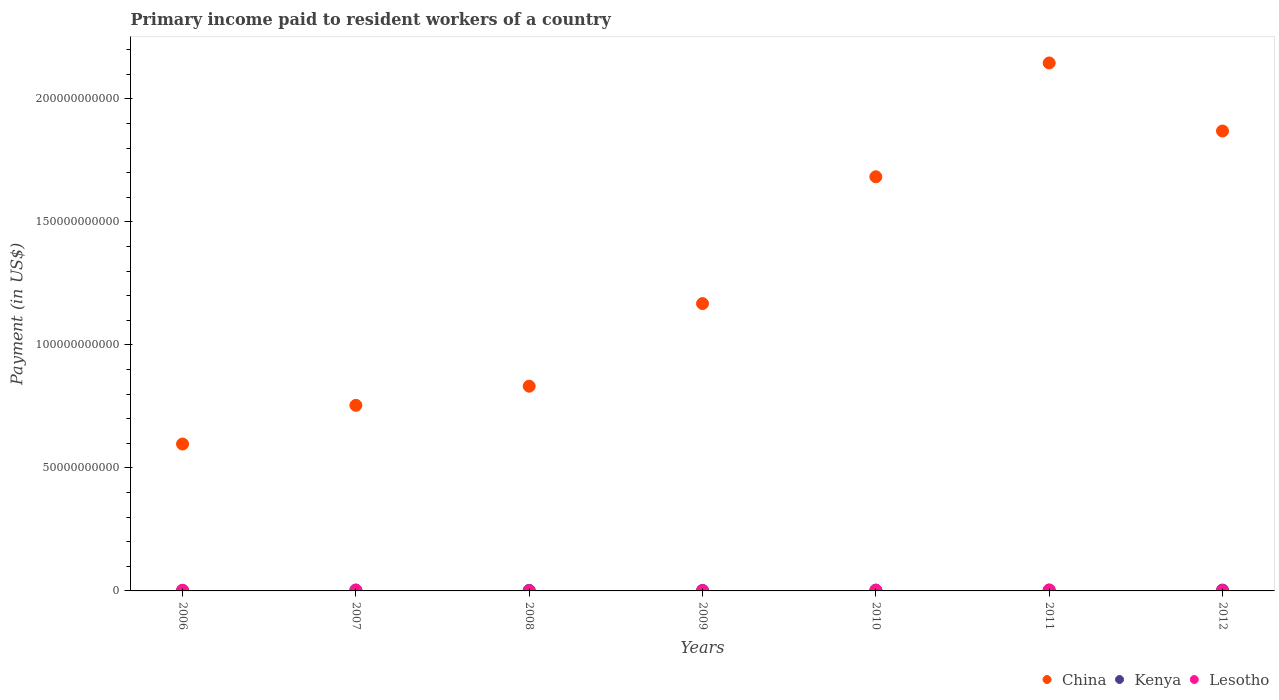Is the number of dotlines equal to the number of legend labels?
Provide a short and direct response. Yes. What is the amount paid to workers in Kenya in 2006?
Your response must be concise. 1.70e+08. Across all years, what is the maximum amount paid to workers in Kenya?
Provide a short and direct response. 3.50e+08. Across all years, what is the minimum amount paid to workers in Kenya?
Offer a terse response. 1.70e+08. In which year was the amount paid to workers in Lesotho maximum?
Your response must be concise. 2011. What is the total amount paid to workers in Lesotho in the graph?
Make the answer very short. 1.71e+09. What is the difference between the amount paid to workers in China in 2009 and that in 2010?
Provide a short and direct response. -5.15e+1. What is the difference between the amount paid to workers in Lesotho in 2008 and the amount paid to workers in Kenya in 2012?
Your answer should be very brief. -2.51e+08. What is the average amount paid to workers in Lesotho per year?
Your answer should be very brief. 2.44e+08. In the year 2008, what is the difference between the amount paid to workers in Lesotho and amount paid to workers in Kenya?
Ensure brevity in your answer.  -1.22e+08. What is the ratio of the amount paid to workers in China in 2007 to that in 2009?
Your answer should be compact. 0.65. Is the difference between the amount paid to workers in Lesotho in 2009 and 2011 greater than the difference between the amount paid to workers in Kenya in 2009 and 2011?
Your response must be concise. No. What is the difference between the highest and the second highest amount paid to workers in Lesotho?
Your answer should be very brief. 2.51e+07. What is the difference between the highest and the lowest amount paid to workers in Kenya?
Ensure brevity in your answer.  1.81e+08. Is the amount paid to workers in China strictly less than the amount paid to workers in Kenya over the years?
Provide a short and direct response. No. How many dotlines are there?
Ensure brevity in your answer.  3. How many years are there in the graph?
Provide a short and direct response. 7. Does the graph contain any zero values?
Provide a short and direct response. No. Does the graph contain grids?
Your answer should be compact. No. Where does the legend appear in the graph?
Provide a short and direct response. Bottom right. How are the legend labels stacked?
Offer a terse response. Horizontal. What is the title of the graph?
Give a very brief answer. Primary income paid to resident workers of a country. Does "Marshall Islands" appear as one of the legend labels in the graph?
Offer a very short reply. No. What is the label or title of the Y-axis?
Your response must be concise. Payment (in US$). What is the Payment (in US$) of China in 2006?
Offer a very short reply. 5.97e+1. What is the Payment (in US$) in Kenya in 2006?
Your response must be concise. 1.70e+08. What is the Payment (in US$) of Lesotho in 2006?
Your response must be concise. 2.65e+08. What is the Payment (in US$) in China in 2007?
Your answer should be compact. 7.54e+1. What is the Payment (in US$) in Kenya in 2007?
Keep it short and to the point. 3.05e+08. What is the Payment (in US$) in Lesotho in 2007?
Provide a succinct answer. 3.70e+08. What is the Payment (in US$) in China in 2008?
Provide a short and direct response. 8.32e+1. What is the Payment (in US$) of Kenya in 2008?
Offer a very short reply. 2.21e+08. What is the Payment (in US$) in Lesotho in 2008?
Your answer should be very brief. 9.93e+07. What is the Payment (in US$) in China in 2009?
Provide a succinct answer. 1.17e+11. What is the Payment (in US$) in Kenya in 2009?
Keep it short and to the point. 2.12e+08. What is the Payment (in US$) of Lesotho in 2009?
Offer a very short reply. 1.25e+08. What is the Payment (in US$) of China in 2010?
Provide a short and direct response. 1.68e+11. What is the Payment (in US$) of Kenya in 2010?
Make the answer very short. 2.92e+08. What is the Payment (in US$) in Lesotho in 2010?
Give a very brief answer. 3.25e+08. What is the Payment (in US$) in China in 2011?
Keep it short and to the point. 2.15e+11. What is the Payment (in US$) in Kenya in 2011?
Your answer should be very brief. 2.83e+08. What is the Payment (in US$) in Lesotho in 2011?
Give a very brief answer. 3.95e+08. What is the Payment (in US$) of China in 2012?
Provide a succinct answer. 1.87e+11. What is the Payment (in US$) of Kenya in 2012?
Keep it short and to the point. 3.50e+08. What is the Payment (in US$) of Lesotho in 2012?
Your answer should be compact. 1.28e+08. Across all years, what is the maximum Payment (in US$) in China?
Provide a succinct answer. 2.15e+11. Across all years, what is the maximum Payment (in US$) in Kenya?
Your answer should be compact. 3.50e+08. Across all years, what is the maximum Payment (in US$) in Lesotho?
Your answer should be very brief. 3.95e+08. Across all years, what is the minimum Payment (in US$) of China?
Ensure brevity in your answer.  5.97e+1. Across all years, what is the minimum Payment (in US$) in Kenya?
Your response must be concise. 1.70e+08. Across all years, what is the minimum Payment (in US$) in Lesotho?
Offer a very short reply. 9.93e+07. What is the total Payment (in US$) of China in the graph?
Offer a very short reply. 9.05e+11. What is the total Payment (in US$) of Kenya in the graph?
Make the answer very short. 1.83e+09. What is the total Payment (in US$) in Lesotho in the graph?
Give a very brief answer. 1.71e+09. What is the difference between the Payment (in US$) of China in 2006 and that in 2007?
Offer a very short reply. -1.57e+1. What is the difference between the Payment (in US$) of Kenya in 2006 and that in 2007?
Offer a very short reply. -1.35e+08. What is the difference between the Payment (in US$) in Lesotho in 2006 and that in 2007?
Your answer should be very brief. -1.05e+08. What is the difference between the Payment (in US$) of China in 2006 and that in 2008?
Make the answer very short. -2.35e+1. What is the difference between the Payment (in US$) in Kenya in 2006 and that in 2008?
Keep it short and to the point. -5.19e+07. What is the difference between the Payment (in US$) of Lesotho in 2006 and that in 2008?
Ensure brevity in your answer.  1.66e+08. What is the difference between the Payment (in US$) of China in 2006 and that in 2009?
Offer a terse response. -5.71e+1. What is the difference between the Payment (in US$) in Kenya in 2006 and that in 2009?
Your answer should be compact. -4.28e+07. What is the difference between the Payment (in US$) of Lesotho in 2006 and that in 2009?
Provide a succinct answer. 1.40e+08. What is the difference between the Payment (in US$) in China in 2006 and that in 2010?
Offer a very short reply. -1.09e+11. What is the difference between the Payment (in US$) of Kenya in 2006 and that in 2010?
Give a very brief answer. -1.22e+08. What is the difference between the Payment (in US$) in Lesotho in 2006 and that in 2010?
Your response must be concise. -5.99e+07. What is the difference between the Payment (in US$) in China in 2006 and that in 2011?
Keep it short and to the point. -1.55e+11. What is the difference between the Payment (in US$) in Kenya in 2006 and that in 2011?
Ensure brevity in your answer.  -1.13e+08. What is the difference between the Payment (in US$) of Lesotho in 2006 and that in 2011?
Offer a very short reply. -1.30e+08. What is the difference between the Payment (in US$) of China in 2006 and that in 2012?
Offer a terse response. -1.27e+11. What is the difference between the Payment (in US$) in Kenya in 2006 and that in 2012?
Offer a terse response. -1.81e+08. What is the difference between the Payment (in US$) in Lesotho in 2006 and that in 2012?
Ensure brevity in your answer.  1.37e+08. What is the difference between the Payment (in US$) of China in 2007 and that in 2008?
Your answer should be very brief. -7.78e+09. What is the difference between the Payment (in US$) of Kenya in 2007 and that in 2008?
Provide a short and direct response. 8.34e+07. What is the difference between the Payment (in US$) in Lesotho in 2007 and that in 2008?
Give a very brief answer. 2.70e+08. What is the difference between the Payment (in US$) in China in 2007 and that in 2009?
Offer a terse response. -4.14e+1. What is the difference between the Payment (in US$) in Kenya in 2007 and that in 2009?
Ensure brevity in your answer.  9.24e+07. What is the difference between the Payment (in US$) in Lesotho in 2007 and that in 2009?
Your answer should be compact. 2.45e+08. What is the difference between the Payment (in US$) in China in 2007 and that in 2010?
Your response must be concise. -9.29e+1. What is the difference between the Payment (in US$) in Kenya in 2007 and that in 2010?
Provide a succinct answer. 1.29e+07. What is the difference between the Payment (in US$) in Lesotho in 2007 and that in 2010?
Your response must be concise. 4.47e+07. What is the difference between the Payment (in US$) of China in 2007 and that in 2011?
Offer a terse response. -1.39e+11. What is the difference between the Payment (in US$) of Kenya in 2007 and that in 2011?
Keep it short and to the point. 2.23e+07. What is the difference between the Payment (in US$) of Lesotho in 2007 and that in 2011?
Keep it short and to the point. -2.51e+07. What is the difference between the Payment (in US$) of China in 2007 and that in 2012?
Give a very brief answer. -1.11e+11. What is the difference between the Payment (in US$) of Kenya in 2007 and that in 2012?
Make the answer very short. -4.56e+07. What is the difference between the Payment (in US$) in Lesotho in 2007 and that in 2012?
Your answer should be very brief. 2.42e+08. What is the difference between the Payment (in US$) of China in 2008 and that in 2009?
Your answer should be compact. -3.36e+1. What is the difference between the Payment (in US$) of Kenya in 2008 and that in 2009?
Your answer should be very brief. 9.07e+06. What is the difference between the Payment (in US$) in Lesotho in 2008 and that in 2009?
Provide a short and direct response. -2.55e+07. What is the difference between the Payment (in US$) of China in 2008 and that in 2010?
Keep it short and to the point. -8.51e+1. What is the difference between the Payment (in US$) in Kenya in 2008 and that in 2010?
Keep it short and to the point. -7.04e+07. What is the difference between the Payment (in US$) in Lesotho in 2008 and that in 2010?
Your answer should be very brief. -2.26e+08. What is the difference between the Payment (in US$) in China in 2008 and that in 2011?
Provide a short and direct response. -1.31e+11. What is the difference between the Payment (in US$) of Kenya in 2008 and that in 2011?
Give a very brief answer. -6.11e+07. What is the difference between the Payment (in US$) of Lesotho in 2008 and that in 2011?
Give a very brief answer. -2.96e+08. What is the difference between the Payment (in US$) of China in 2008 and that in 2012?
Your answer should be very brief. -1.04e+11. What is the difference between the Payment (in US$) in Kenya in 2008 and that in 2012?
Your answer should be very brief. -1.29e+08. What is the difference between the Payment (in US$) in Lesotho in 2008 and that in 2012?
Offer a terse response. -2.85e+07. What is the difference between the Payment (in US$) of China in 2009 and that in 2010?
Your response must be concise. -5.15e+1. What is the difference between the Payment (in US$) of Kenya in 2009 and that in 2010?
Offer a very short reply. -7.95e+07. What is the difference between the Payment (in US$) of Lesotho in 2009 and that in 2010?
Ensure brevity in your answer.  -2.00e+08. What is the difference between the Payment (in US$) of China in 2009 and that in 2011?
Keep it short and to the point. -9.78e+1. What is the difference between the Payment (in US$) of Kenya in 2009 and that in 2011?
Provide a short and direct response. -7.02e+07. What is the difference between the Payment (in US$) of Lesotho in 2009 and that in 2011?
Give a very brief answer. -2.70e+08. What is the difference between the Payment (in US$) in China in 2009 and that in 2012?
Provide a short and direct response. -7.01e+1. What is the difference between the Payment (in US$) of Kenya in 2009 and that in 2012?
Offer a terse response. -1.38e+08. What is the difference between the Payment (in US$) of Lesotho in 2009 and that in 2012?
Offer a very short reply. -3.08e+06. What is the difference between the Payment (in US$) of China in 2010 and that in 2011?
Ensure brevity in your answer.  -4.63e+1. What is the difference between the Payment (in US$) of Kenya in 2010 and that in 2011?
Make the answer very short. 9.34e+06. What is the difference between the Payment (in US$) in Lesotho in 2010 and that in 2011?
Provide a short and direct response. -6.97e+07. What is the difference between the Payment (in US$) of China in 2010 and that in 2012?
Provide a succinct answer. -1.86e+1. What is the difference between the Payment (in US$) of Kenya in 2010 and that in 2012?
Provide a short and direct response. -5.85e+07. What is the difference between the Payment (in US$) of Lesotho in 2010 and that in 2012?
Ensure brevity in your answer.  1.97e+08. What is the difference between the Payment (in US$) of China in 2011 and that in 2012?
Your answer should be very brief. 2.77e+1. What is the difference between the Payment (in US$) of Kenya in 2011 and that in 2012?
Provide a short and direct response. -6.79e+07. What is the difference between the Payment (in US$) of Lesotho in 2011 and that in 2012?
Your answer should be very brief. 2.67e+08. What is the difference between the Payment (in US$) of China in 2006 and the Payment (in US$) of Kenya in 2007?
Offer a very short reply. 5.94e+1. What is the difference between the Payment (in US$) of China in 2006 and the Payment (in US$) of Lesotho in 2007?
Give a very brief answer. 5.93e+1. What is the difference between the Payment (in US$) in Kenya in 2006 and the Payment (in US$) in Lesotho in 2007?
Keep it short and to the point. -2.00e+08. What is the difference between the Payment (in US$) of China in 2006 and the Payment (in US$) of Kenya in 2008?
Your answer should be compact. 5.95e+1. What is the difference between the Payment (in US$) in China in 2006 and the Payment (in US$) in Lesotho in 2008?
Make the answer very short. 5.96e+1. What is the difference between the Payment (in US$) in Kenya in 2006 and the Payment (in US$) in Lesotho in 2008?
Make the answer very short. 7.02e+07. What is the difference between the Payment (in US$) of China in 2006 and the Payment (in US$) of Kenya in 2009?
Offer a very short reply. 5.95e+1. What is the difference between the Payment (in US$) of China in 2006 and the Payment (in US$) of Lesotho in 2009?
Your response must be concise. 5.96e+1. What is the difference between the Payment (in US$) in Kenya in 2006 and the Payment (in US$) in Lesotho in 2009?
Give a very brief answer. 4.47e+07. What is the difference between the Payment (in US$) of China in 2006 and the Payment (in US$) of Kenya in 2010?
Offer a very short reply. 5.94e+1. What is the difference between the Payment (in US$) of China in 2006 and the Payment (in US$) of Lesotho in 2010?
Give a very brief answer. 5.94e+1. What is the difference between the Payment (in US$) of Kenya in 2006 and the Payment (in US$) of Lesotho in 2010?
Offer a terse response. -1.56e+08. What is the difference between the Payment (in US$) of China in 2006 and the Payment (in US$) of Kenya in 2011?
Keep it short and to the point. 5.94e+1. What is the difference between the Payment (in US$) of China in 2006 and the Payment (in US$) of Lesotho in 2011?
Give a very brief answer. 5.93e+1. What is the difference between the Payment (in US$) in Kenya in 2006 and the Payment (in US$) in Lesotho in 2011?
Offer a very short reply. -2.25e+08. What is the difference between the Payment (in US$) of China in 2006 and the Payment (in US$) of Kenya in 2012?
Make the answer very short. 5.94e+1. What is the difference between the Payment (in US$) of China in 2006 and the Payment (in US$) of Lesotho in 2012?
Your response must be concise. 5.96e+1. What is the difference between the Payment (in US$) of Kenya in 2006 and the Payment (in US$) of Lesotho in 2012?
Ensure brevity in your answer.  4.16e+07. What is the difference between the Payment (in US$) of China in 2007 and the Payment (in US$) of Kenya in 2008?
Ensure brevity in your answer.  7.52e+1. What is the difference between the Payment (in US$) of China in 2007 and the Payment (in US$) of Lesotho in 2008?
Make the answer very short. 7.53e+1. What is the difference between the Payment (in US$) in Kenya in 2007 and the Payment (in US$) in Lesotho in 2008?
Give a very brief answer. 2.05e+08. What is the difference between the Payment (in US$) in China in 2007 and the Payment (in US$) in Kenya in 2009?
Ensure brevity in your answer.  7.52e+1. What is the difference between the Payment (in US$) of China in 2007 and the Payment (in US$) of Lesotho in 2009?
Offer a very short reply. 7.53e+1. What is the difference between the Payment (in US$) of Kenya in 2007 and the Payment (in US$) of Lesotho in 2009?
Offer a terse response. 1.80e+08. What is the difference between the Payment (in US$) of China in 2007 and the Payment (in US$) of Kenya in 2010?
Your answer should be very brief. 7.51e+1. What is the difference between the Payment (in US$) in China in 2007 and the Payment (in US$) in Lesotho in 2010?
Provide a succinct answer. 7.51e+1. What is the difference between the Payment (in US$) in Kenya in 2007 and the Payment (in US$) in Lesotho in 2010?
Ensure brevity in your answer.  -2.04e+07. What is the difference between the Payment (in US$) in China in 2007 and the Payment (in US$) in Kenya in 2011?
Give a very brief answer. 7.51e+1. What is the difference between the Payment (in US$) of China in 2007 and the Payment (in US$) of Lesotho in 2011?
Make the answer very short. 7.50e+1. What is the difference between the Payment (in US$) in Kenya in 2007 and the Payment (in US$) in Lesotho in 2011?
Make the answer very short. -9.01e+07. What is the difference between the Payment (in US$) in China in 2007 and the Payment (in US$) in Kenya in 2012?
Offer a terse response. 7.51e+1. What is the difference between the Payment (in US$) of China in 2007 and the Payment (in US$) of Lesotho in 2012?
Ensure brevity in your answer.  7.53e+1. What is the difference between the Payment (in US$) in Kenya in 2007 and the Payment (in US$) in Lesotho in 2012?
Offer a terse response. 1.77e+08. What is the difference between the Payment (in US$) of China in 2008 and the Payment (in US$) of Kenya in 2009?
Give a very brief answer. 8.30e+1. What is the difference between the Payment (in US$) of China in 2008 and the Payment (in US$) of Lesotho in 2009?
Provide a short and direct response. 8.31e+1. What is the difference between the Payment (in US$) in Kenya in 2008 and the Payment (in US$) in Lesotho in 2009?
Provide a succinct answer. 9.66e+07. What is the difference between the Payment (in US$) in China in 2008 and the Payment (in US$) in Kenya in 2010?
Offer a terse response. 8.29e+1. What is the difference between the Payment (in US$) of China in 2008 and the Payment (in US$) of Lesotho in 2010?
Offer a terse response. 8.29e+1. What is the difference between the Payment (in US$) in Kenya in 2008 and the Payment (in US$) in Lesotho in 2010?
Your response must be concise. -1.04e+08. What is the difference between the Payment (in US$) in China in 2008 and the Payment (in US$) in Kenya in 2011?
Offer a very short reply. 8.29e+1. What is the difference between the Payment (in US$) in China in 2008 and the Payment (in US$) in Lesotho in 2011?
Provide a succinct answer. 8.28e+1. What is the difference between the Payment (in US$) in Kenya in 2008 and the Payment (in US$) in Lesotho in 2011?
Your answer should be compact. -1.73e+08. What is the difference between the Payment (in US$) of China in 2008 and the Payment (in US$) of Kenya in 2012?
Provide a short and direct response. 8.29e+1. What is the difference between the Payment (in US$) of China in 2008 and the Payment (in US$) of Lesotho in 2012?
Make the answer very short. 8.31e+1. What is the difference between the Payment (in US$) in Kenya in 2008 and the Payment (in US$) in Lesotho in 2012?
Provide a succinct answer. 9.35e+07. What is the difference between the Payment (in US$) in China in 2009 and the Payment (in US$) in Kenya in 2010?
Give a very brief answer. 1.16e+11. What is the difference between the Payment (in US$) of China in 2009 and the Payment (in US$) of Lesotho in 2010?
Your response must be concise. 1.16e+11. What is the difference between the Payment (in US$) of Kenya in 2009 and the Payment (in US$) of Lesotho in 2010?
Provide a succinct answer. -1.13e+08. What is the difference between the Payment (in US$) of China in 2009 and the Payment (in US$) of Kenya in 2011?
Provide a succinct answer. 1.17e+11. What is the difference between the Payment (in US$) of China in 2009 and the Payment (in US$) of Lesotho in 2011?
Keep it short and to the point. 1.16e+11. What is the difference between the Payment (in US$) in Kenya in 2009 and the Payment (in US$) in Lesotho in 2011?
Your response must be concise. -1.83e+08. What is the difference between the Payment (in US$) of China in 2009 and the Payment (in US$) of Kenya in 2012?
Your response must be concise. 1.16e+11. What is the difference between the Payment (in US$) of China in 2009 and the Payment (in US$) of Lesotho in 2012?
Offer a very short reply. 1.17e+11. What is the difference between the Payment (in US$) of Kenya in 2009 and the Payment (in US$) of Lesotho in 2012?
Offer a terse response. 8.45e+07. What is the difference between the Payment (in US$) in China in 2010 and the Payment (in US$) in Kenya in 2011?
Give a very brief answer. 1.68e+11. What is the difference between the Payment (in US$) in China in 2010 and the Payment (in US$) in Lesotho in 2011?
Your response must be concise. 1.68e+11. What is the difference between the Payment (in US$) of Kenya in 2010 and the Payment (in US$) of Lesotho in 2011?
Provide a succinct answer. -1.03e+08. What is the difference between the Payment (in US$) in China in 2010 and the Payment (in US$) in Kenya in 2012?
Ensure brevity in your answer.  1.68e+11. What is the difference between the Payment (in US$) of China in 2010 and the Payment (in US$) of Lesotho in 2012?
Your response must be concise. 1.68e+11. What is the difference between the Payment (in US$) of Kenya in 2010 and the Payment (in US$) of Lesotho in 2012?
Make the answer very short. 1.64e+08. What is the difference between the Payment (in US$) of China in 2011 and the Payment (in US$) of Kenya in 2012?
Ensure brevity in your answer.  2.14e+11. What is the difference between the Payment (in US$) in China in 2011 and the Payment (in US$) in Lesotho in 2012?
Provide a succinct answer. 2.14e+11. What is the difference between the Payment (in US$) of Kenya in 2011 and the Payment (in US$) of Lesotho in 2012?
Your answer should be very brief. 1.55e+08. What is the average Payment (in US$) of China per year?
Your response must be concise. 1.29e+11. What is the average Payment (in US$) in Kenya per year?
Ensure brevity in your answer.  2.62e+08. What is the average Payment (in US$) in Lesotho per year?
Provide a succinct answer. 2.44e+08. In the year 2006, what is the difference between the Payment (in US$) of China and Payment (in US$) of Kenya?
Make the answer very short. 5.95e+1. In the year 2006, what is the difference between the Payment (in US$) of China and Payment (in US$) of Lesotho?
Offer a terse response. 5.94e+1. In the year 2006, what is the difference between the Payment (in US$) of Kenya and Payment (in US$) of Lesotho?
Give a very brief answer. -9.58e+07. In the year 2007, what is the difference between the Payment (in US$) of China and Payment (in US$) of Kenya?
Your answer should be compact. 7.51e+1. In the year 2007, what is the difference between the Payment (in US$) in China and Payment (in US$) in Lesotho?
Offer a terse response. 7.51e+1. In the year 2007, what is the difference between the Payment (in US$) in Kenya and Payment (in US$) in Lesotho?
Ensure brevity in your answer.  -6.50e+07. In the year 2008, what is the difference between the Payment (in US$) in China and Payment (in US$) in Kenya?
Keep it short and to the point. 8.30e+1. In the year 2008, what is the difference between the Payment (in US$) of China and Payment (in US$) of Lesotho?
Provide a short and direct response. 8.31e+1. In the year 2008, what is the difference between the Payment (in US$) of Kenya and Payment (in US$) of Lesotho?
Offer a terse response. 1.22e+08. In the year 2009, what is the difference between the Payment (in US$) in China and Payment (in US$) in Kenya?
Offer a very short reply. 1.17e+11. In the year 2009, what is the difference between the Payment (in US$) in China and Payment (in US$) in Lesotho?
Your answer should be compact. 1.17e+11. In the year 2009, what is the difference between the Payment (in US$) in Kenya and Payment (in US$) in Lesotho?
Keep it short and to the point. 8.75e+07. In the year 2010, what is the difference between the Payment (in US$) of China and Payment (in US$) of Kenya?
Keep it short and to the point. 1.68e+11. In the year 2010, what is the difference between the Payment (in US$) of China and Payment (in US$) of Lesotho?
Give a very brief answer. 1.68e+11. In the year 2010, what is the difference between the Payment (in US$) in Kenya and Payment (in US$) in Lesotho?
Offer a very short reply. -3.33e+07. In the year 2011, what is the difference between the Payment (in US$) of China and Payment (in US$) of Kenya?
Keep it short and to the point. 2.14e+11. In the year 2011, what is the difference between the Payment (in US$) in China and Payment (in US$) in Lesotho?
Your response must be concise. 2.14e+11. In the year 2011, what is the difference between the Payment (in US$) in Kenya and Payment (in US$) in Lesotho?
Give a very brief answer. -1.12e+08. In the year 2012, what is the difference between the Payment (in US$) in China and Payment (in US$) in Kenya?
Your answer should be very brief. 1.87e+11. In the year 2012, what is the difference between the Payment (in US$) of China and Payment (in US$) of Lesotho?
Provide a succinct answer. 1.87e+11. In the year 2012, what is the difference between the Payment (in US$) of Kenya and Payment (in US$) of Lesotho?
Your response must be concise. 2.23e+08. What is the ratio of the Payment (in US$) of China in 2006 to that in 2007?
Your response must be concise. 0.79. What is the ratio of the Payment (in US$) in Kenya in 2006 to that in 2007?
Provide a succinct answer. 0.56. What is the ratio of the Payment (in US$) in Lesotho in 2006 to that in 2007?
Provide a short and direct response. 0.72. What is the ratio of the Payment (in US$) in China in 2006 to that in 2008?
Give a very brief answer. 0.72. What is the ratio of the Payment (in US$) in Kenya in 2006 to that in 2008?
Ensure brevity in your answer.  0.77. What is the ratio of the Payment (in US$) in Lesotho in 2006 to that in 2008?
Provide a short and direct response. 2.67. What is the ratio of the Payment (in US$) in China in 2006 to that in 2009?
Your response must be concise. 0.51. What is the ratio of the Payment (in US$) in Kenya in 2006 to that in 2009?
Your response must be concise. 0.8. What is the ratio of the Payment (in US$) in Lesotho in 2006 to that in 2009?
Make the answer very short. 2.13. What is the ratio of the Payment (in US$) of China in 2006 to that in 2010?
Give a very brief answer. 0.35. What is the ratio of the Payment (in US$) of Kenya in 2006 to that in 2010?
Offer a very short reply. 0.58. What is the ratio of the Payment (in US$) in Lesotho in 2006 to that in 2010?
Offer a terse response. 0.82. What is the ratio of the Payment (in US$) in China in 2006 to that in 2011?
Provide a short and direct response. 0.28. What is the ratio of the Payment (in US$) of Kenya in 2006 to that in 2011?
Offer a terse response. 0.6. What is the ratio of the Payment (in US$) of Lesotho in 2006 to that in 2011?
Ensure brevity in your answer.  0.67. What is the ratio of the Payment (in US$) in China in 2006 to that in 2012?
Your answer should be very brief. 0.32. What is the ratio of the Payment (in US$) in Kenya in 2006 to that in 2012?
Make the answer very short. 0.48. What is the ratio of the Payment (in US$) in Lesotho in 2006 to that in 2012?
Give a very brief answer. 2.07. What is the ratio of the Payment (in US$) in China in 2007 to that in 2008?
Your answer should be very brief. 0.91. What is the ratio of the Payment (in US$) of Kenya in 2007 to that in 2008?
Keep it short and to the point. 1.38. What is the ratio of the Payment (in US$) in Lesotho in 2007 to that in 2008?
Offer a very short reply. 3.72. What is the ratio of the Payment (in US$) of China in 2007 to that in 2009?
Ensure brevity in your answer.  0.65. What is the ratio of the Payment (in US$) of Kenya in 2007 to that in 2009?
Ensure brevity in your answer.  1.44. What is the ratio of the Payment (in US$) of Lesotho in 2007 to that in 2009?
Ensure brevity in your answer.  2.96. What is the ratio of the Payment (in US$) of China in 2007 to that in 2010?
Make the answer very short. 0.45. What is the ratio of the Payment (in US$) of Kenya in 2007 to that in 2010?
Ensure brevity in your answer.  1.04. What is the ratio of the Payment (in US$) of Lesotho in 2007 to that in 2010?
Offer a terse response. 1.14. What is the ratio of the Payment (in US$) in China in 2007 to that in 2011?
Your answer should be compact. 0.35. What is the ratio of the Payment (in US$) of Kenya in 2007 to that in 2011?
Your response must be concise. 1.08. What is the ratio of the Payment (in US$) of Lesotho in 2007 to that in 2011?
Give a very brief answer. 0.94. What is the ratio of the Payment (in US$) in China in 2007 to that in 2012?
Ensure brevity in your answer.  0.4. What is the ratio of the Payment (in US$) in Kenya in 2007 to that in 2012?
Offer a terse response. 0.87. What is the ratio of the Payment (in US$) of Lesotho in 2007 to that in 2012?
Offer a very short reply. 2.89. What is the ratio of the Payment (in US$) of China in 2008 to that in 2009?
Provide a succinct answer. 0.71. What is the ratio of the Payment (in US$) in Kenya in 2008 to that in 2009?
Ensure brevity in your answer.  1.04. What is the ratio of the Payment (in US$) in Lesotho in 2008 to that in 2009?
Ensure brevity in your answer.  0.8. What is the ratio of the Payment (in US$) in China in 2008 to that in 2010?
Keep it short and to the point. 0.49. What is the ratio of the Payment (in US$) of Kenya in 2008 to that in 2010?
Offer a terse response. 0.76. What is the ratio of the Payment (in US$) in Lesotho in 2008 to that in 2010?
Keep it short and to the point. 0.31. What is the ratio of the Payment (in US$) of China in 2008 to that in 2011?
Provide a succinct answer. 0.39. What is the ratio of the Payment (in US$) of Kenya in 2008 to that in 2011?
Ensure brevity in your answer.  0.78. What is the ratio of the Payment (in US$) in Lesotho in 2008 to that in 2011?
Keep it short and to the point. 0.25. What is the ratio of the Payment (in US$) in China in 2008 to that in 2012?
Provide a succinct answer. 0.45. What is the ratio of the Payment (in US$) in Kenya in 2008 to that in 2012?
Keep it short and to the point. 0.63. What is the ratio of the Payment (in US$) in Lesotho in 2008 to that in 2012?
Offer a very short reply. 0.78. What is the ratio of the Payment (in US$) of China in 2009 to that in 2010?
Keep it short and to the point. 0.69. What is the ratio of the Payment (in US$) in Kenya in 2009 to that in 2010?
Provide a short and direct response. 0.73. What is the ratio of the Payment (in US$) in Lesotho in 2009 to that in 2010?
Your answer should be compact. 0.38. What is the ratio of the Payment (in US$) of China in 2009 to that in 2011?
Your response must be concise. 0.54. What is the ratio of the Payment (in US$) in Kenya in 2009 to that in 2011?
Keep it short and to the point. 0.75. What is the ratio of the Payment (in US$) in Lesotho in 2009 to that in 2011?
Ensure brevity in your answer.  0.32. What is the ratio of the Payment (in US$) of China in 2009 to that in 2012?
Provide a succinct answer. 0.62. What is the ratio of the Payment (in US$) in Kenya in 2009 to that in 2012?
Ensure brevity in your answer.  0.61. What is the ratio of the Payment (in US$) of Lesotho in 2009 to that in 2012?
Ensure brevity in your answer.  0.98. What is the ratio of the Payment (in US$) of China in 2010 to that in 2011?
Your response must be concise. 0.78. What is the ratio of the Payment (in US$) in Kenya in 2010 to that in 2011?
Make the answer very short. 1.03. What is the ratio of the Payment (in US$) in Lesotho in 2010 to that in 2011?
Give a very brief answer. 0.82. What is the ratio of the Payment (in US$) in China in 2010 to that in 2012?
Make the answer very short. 0.9. What is the ratio of the Payment (in US$) of Kenya in 2010 to that in 2012?
Ensure brevity in your answer.  0.83. What is the ratio of the Payment (in US$) of Lesotho in 2010 to that in 2012?
Your response must be concise. 2.54. What is the ratio of the Payment (in US$) in China in 2011 to that in 2012?
Ensure brevity in your answer.  1.15. What is the ratio of the Payment (in US$) of Kenya in 2011 to that in 2012?
Your answer should be very brief. 0.81. What is the ratio of the Payment (in US$) in Lesotho in 2011 to that in 2012?
Keep it short and to the point. 3.09. What is the difference between the highest and the second highest Payment (in US$) of China?
Ensure brevity in your answer.  2.77e+1. What is the difference between the highest and the second highest Payment (in US$) in Kenya?
Ensure brevity in your answer.  4.56e+07. What is the difference between the highest and the second highest Payment (in US$) of Lesotho?
Your answer should be compact. 2.51e+07. What is the difference between the highest and the lowest Payment (in US$) of China?
Make the answer very short. 1.55e+11. What is the difference between the highest and the lowest Payment (in US$) of Kenya?
Your response must be concise. 1.81e+08. What is the difference between the highest and the lowest Payment (in US$) in Lesotho?
Provide a short and direct response. 2.96e+08. 